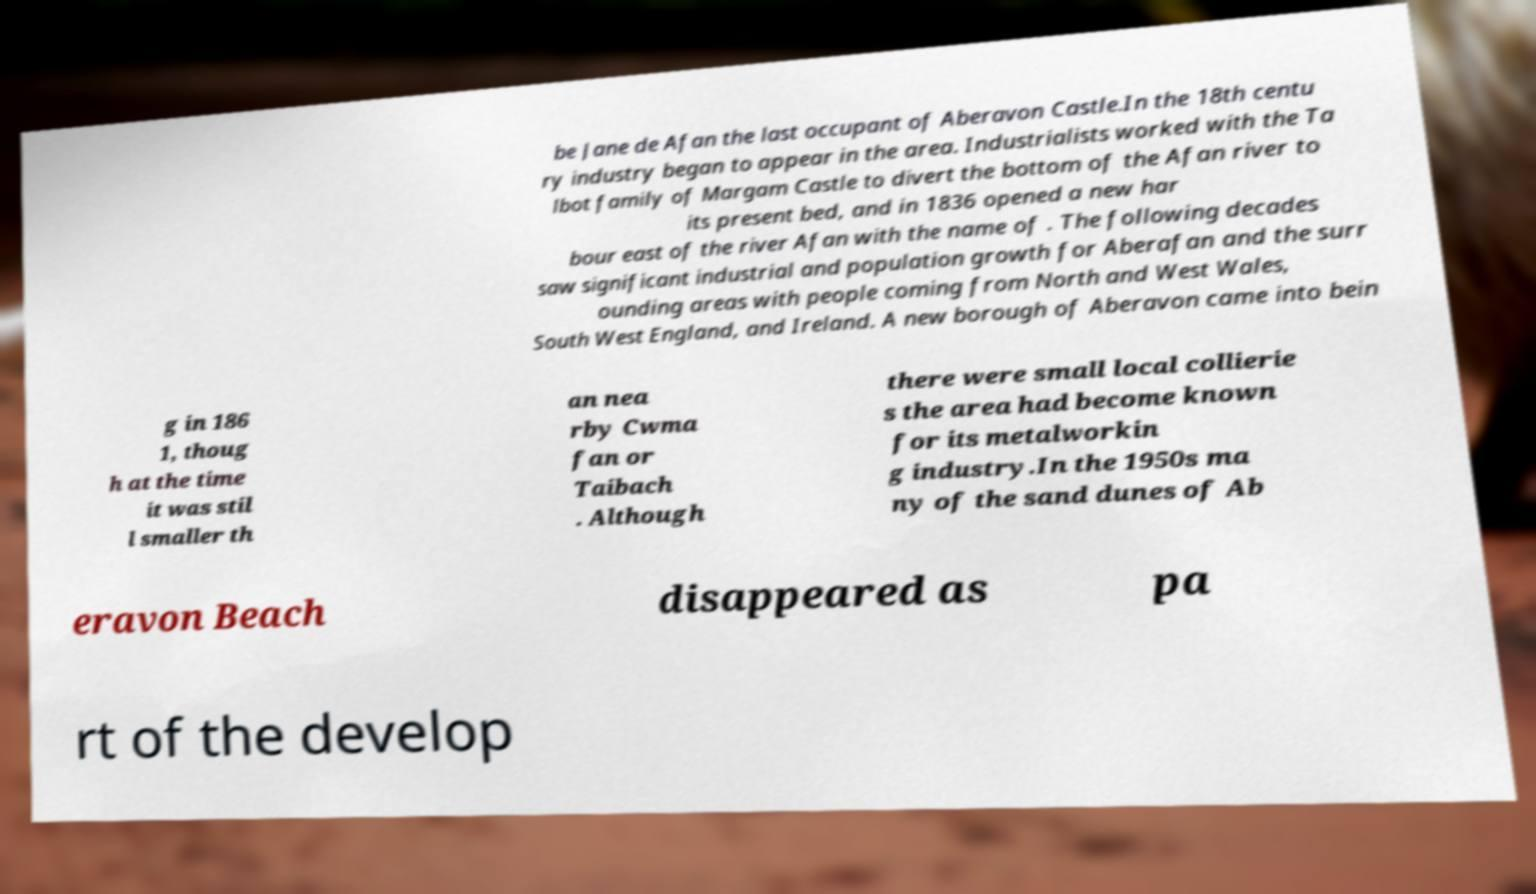Can you accurately transcribe the text from the provided image for me? be Jane de Afan the last occupant of Aberavon Castle.In the 18th centu ry industry began to appear in the area. Industrialists worked with the Ta lbot family of Margam Castle to divert the bottom of the Afan river to its present bed, and in 1836 opened a new har bour east of the river Afan with the name of . The following decades saw significant industrial and population growth for Aberafan and the surr ounding areas with people coming from North and West Wales, South West England, and Ireland. A new borough of Aberavon came into bein g in 186 1, thoug h at the time it was stil l smaller th an nea rby Cwma fan or Taibach . Although there were small local collierie s the area had become known for its metalworkin g industry.In the 1950s ma ny of the sand dunes of Ab eravon Beach disappeared as pa rt of the develop 